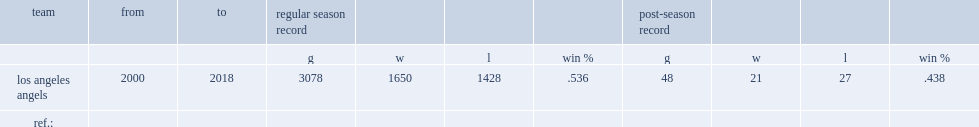When did scioscia begin to manage the los angeles angels? 2000.0 2018.0. 